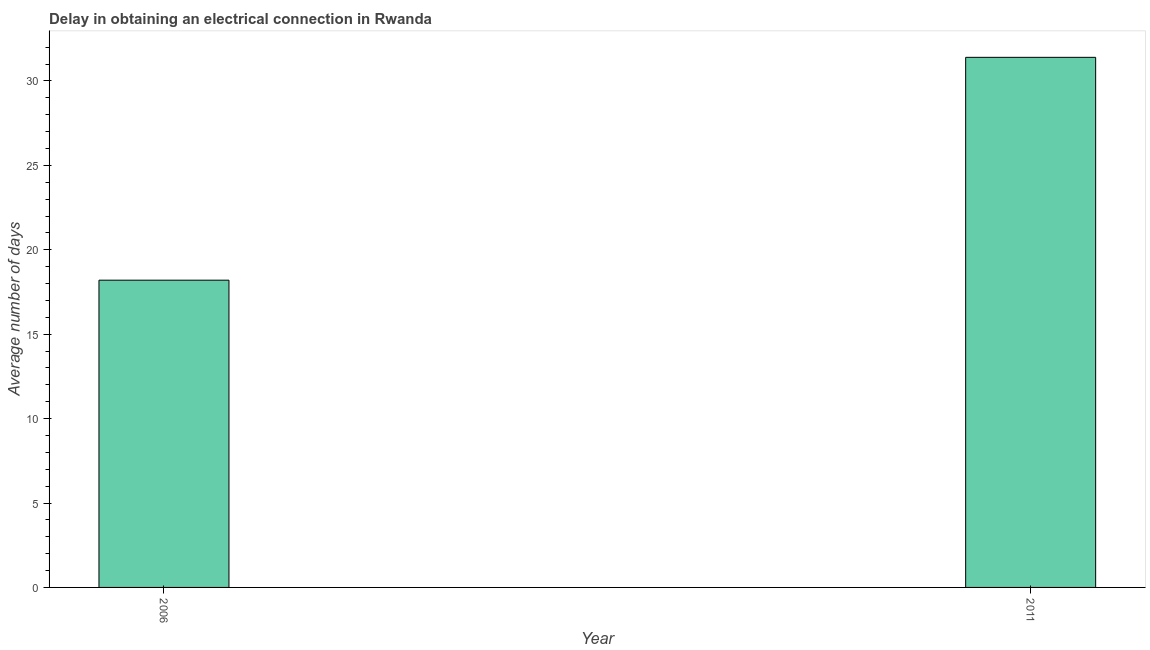Does the graph contain any zero values?
Your response must be concise. No. What is the title of the graph?
Make the answer very short. Delay in obtaining an electrical connection in Rwanda. What is the label or title of the X-axis?
Offer a very short reply. Year. What is the label or title of the Y-axis?
Offer a very short reply. Average number of days. What is the dalay in electrical connection in 2006?
Your answer should be very brief. 18.2. Across all years, what is the maximum dalay in electrical connection?
Provide a short and direct response. 31.4. What is the sum of the dalay in electrical connection?
Make the answer very short. 49.6. What is the average dalay in electrical connection per year?
Give a very brief answer. 24.8. What is the median dalay in electrical connection?
Offer a very short reply. 24.8. In how many years, is the dalay in electrical connection greater than 28 days?
Make the answer very short. 1. What is the ratio of the dalay in electrical connection in 2006 to that in 2011?
Provide a succinct answer. 0.58. How many bars are there?
Your answer should be very brief. 2. How many years are there in the graph?
Your answer should be compact. 2. What is the difference between two consecutive major ticks on the Y-axis?
Provide a succinct answer. 5. Are the values on the major ticks of Y-axis written in scientific E-notation?
Provide a short and direct response. No. What is the Average number of days in 2011?
Offer a terse response. 31.4. What is the ratio of the Average number of days in 2006 to that in 2011?
Make the answer very short. 0.58. 